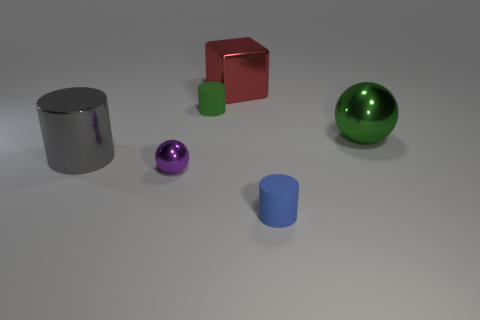Could you describe any patterns of symmetry or alignment among the objects? While there's no precise symmetry in the placement of the objects, there is a sense of balance. The objects are arranged with some space between them, creating a diagonal line from the top left to the bottom right which roughly divides the scene into two, providing a balanced visual composition. 